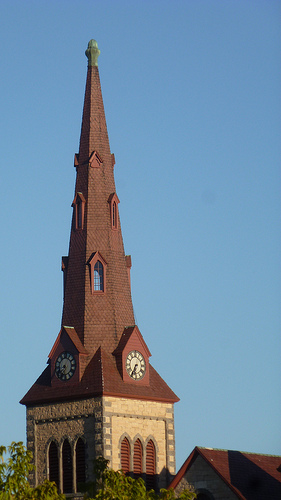What time do the clocks show? It's difficult to determine the exact time as the image resolution doesn't allow for a clear view of the clock faces; however, the position of the hands suggests it could be around ten past ten. 